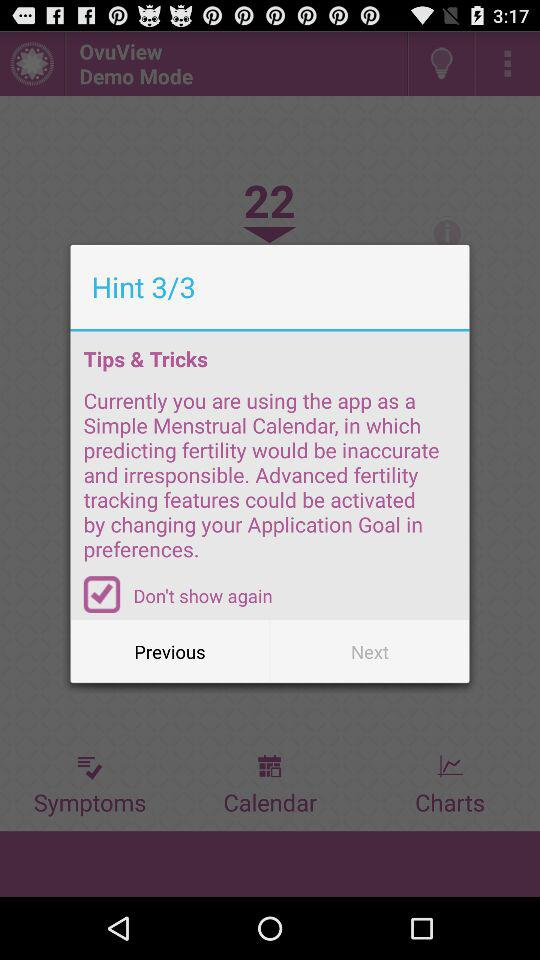Is "Don't show again" checked or unchecked? "Don't show again" is checked. 